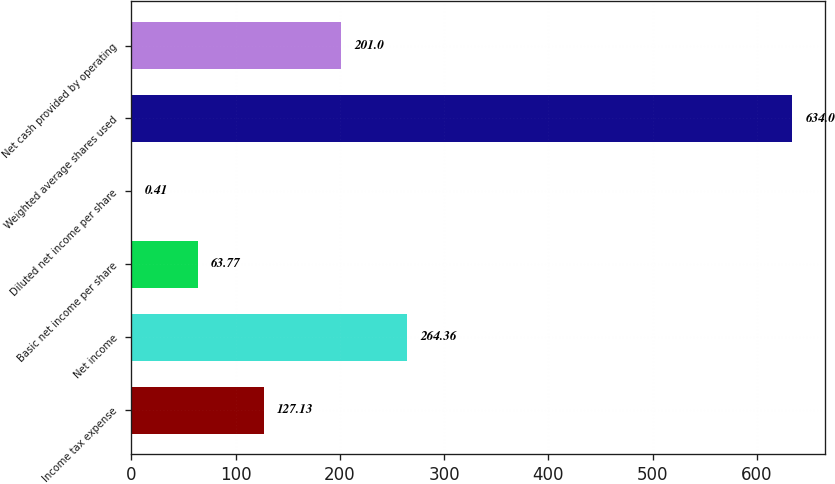Convert chart. <chart><loc_0><loc_0><loc_500><loc_500><bar_chart><fcel>Income tax expense<fcel>Net income<fcel>Basic net income per share<fcel>Diluted net income per share<fcel>Weighted average shares used<fcel>Net cash provided by operating<nl><fcel>127.13<fcel>264.36<fcel>63.77<fcel>0.41<fcel>634<fcel>201<nl></chart> 